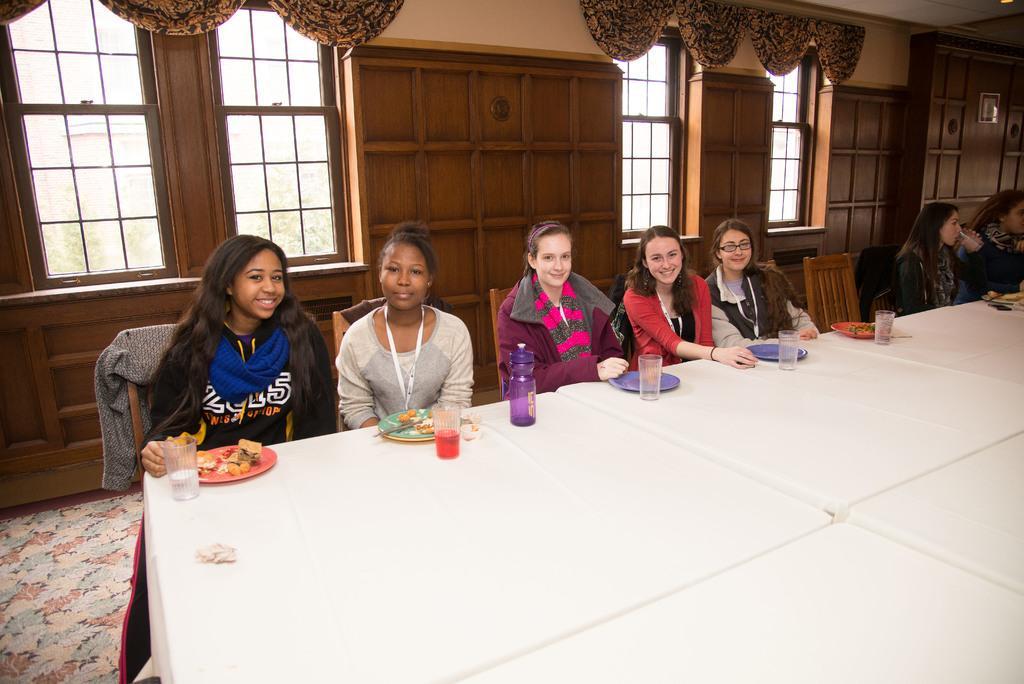How would you summarize this image in a sentence or two? group of women are placed on the wooden chair. In-front of their,There are few white tables and plates, glass with water, bottle, juice. some food are placed on the plates. At the background, we can see wooden wall and glass window ,curtains and cream color wall. On the right side, we can see a Frame. 